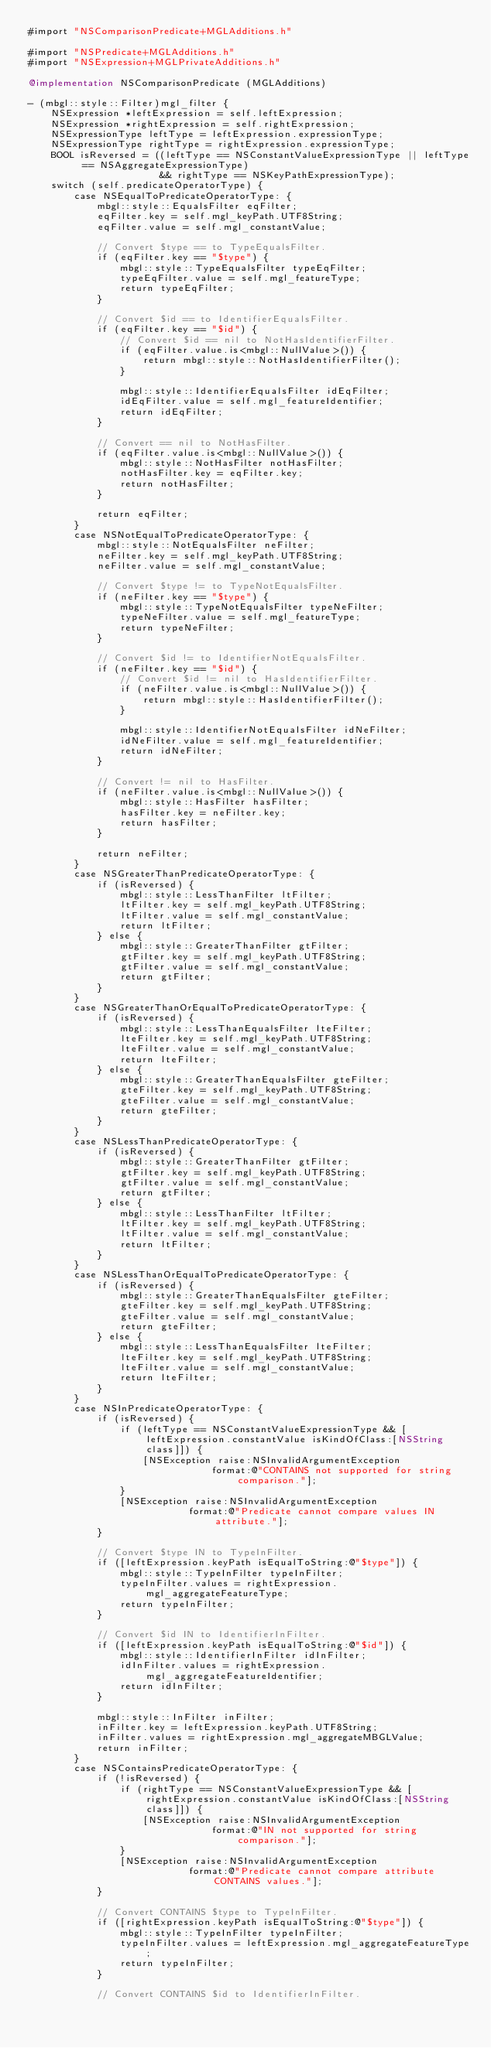<code> <loc_0><loc_0><loc_500><loc_500><_ObjectiveC_>#import "NSComparisonPredicate+MGLAdditions.h"

#import "NSPredicate+MGLAdditions.h"
#import "NSExpression+MGLPrivateAdditions.h"

@implementation NSComparisonPredicate (MGLAdditions)

- (mbgl::style::Filter)mgl_filter {
    NSExpression *leftExpression = self.leftExpression;
    NSExpression *rightExpression = self.rightExpression;
    NSExpressionType leftType = leftExpression.expressionType;
    NSExpressionType rightType = rightExpression.expressionType;
    BOOL isReversed = ((leftType == NSConstantValueExpressionType || leftType == NSAggregateExpressionType)
                       && rightType == NSKeyPathExpressionType);
    switch (self.predicateOperatorType) {
        case NSEqualToPredicateOperatorType: {
            mbgl::style::EqualsFilter eqFilter;
            eqFilter.key = self.mgl_keyPath.UTF8String;
            eqFilter.value = self.mgl_constantValue;
            
            // Convert $type == to TypeEqualsFilter.
            if (eqFilter.key == "$type") {
                mbgl::style::TypeEqualsFilter typeEqFilter;
                typeEqFilter.value = self.mgl_featureType;
                return typeEqFilter;
            }
            
            // Convert $id == to IdentifierEqualsFilter.
            if (eqFilter.key == "$id") {
                // Convert $id == nil to NotHasIdentifierFilter.
                if (eqFilter.value.is<mbgl::NullValue>()) {
                    return mbgl::style::NotHasIdentifierFilter();
                }
                
                mbgl::style::IdentifierEqualsFilter idEqFilter;
                idEqFilter.value = self.mgl_featureIdentifier;
                return idEqFilter;
            }

            // Convert == nil to NotHasFilter.
            if (eqFilter.value.is<mbgl::NullValue>()) {
                mbgl::style::NotHasFilter notHasFilter;
                notHasFilter.key = eqFilter.key;
                return notHasFilter;
            }

            return eqFilter;
        }
        case NSNotEqualToPredicateOperatorType: {
            mbgl::style::NotEqualsFilter neFilter;
            neFilter.key = self.mgl_keyPath.UTF8String;
            neFilter.value = self.mgl_constantValue;
            
            // Convert $type != to TypeNotEqualsFilter.
            if (neFilter.key == "$type") {
                mbgl::style::TypeNotEqualsFilter typeNeFilter;
                typeNeFilter.value = self.mgl_featureType;
                return typeNeFilter;
            }
            
            // Convert $id != to IdentifierNotEqualsFilter.
            if (neFilter.key == "$id") {
                // Convert $id != nil to HasIdentifierFilter.
                if (neFilter.value.is<mbgl::NullValue>()) {
                    return mbgl::style::HasIdentifierFilter();
                }
                
                mbgl::style::IdentifierNotEqualsFilter idNeFilter;
                idNeFilter.value = self.mgl_featureIdentifier;
                return idNeFilter;
            }

            // Convert != nil to HasFilter.
            if (neFilter.value.is<mbgl::NullValue>()) {
                mbgl::style::HasFilter hasFilter;
                hasFilter.key = neFilter.key;
                return hasFilter;
            }

            return neFilter;
        }
        case NSGreaterThanPredicateOperatorType: {
            if (isReversed) {
                mbgl::style::LessThanFilter ltFilter;
                ltFilter.key = self.mgl_keyPath.UTF8String;
                ltFilter.value = self.mgl_constantValue;
                return ltFilter;
            } else {
                mbgl::style::GreaterThanFilter gtFilter;
                gtFilter.key = self.mgl_keyPath.UTF8String;
                gtFilter.value = self.mgl_constantValue;
                return gtFilter;
            }
        }
        case NSGreaterThanOrEqualToPredicateOperatorType: {
            if (isReversed) {
                mbgl::style::LessThanEqualsFilter lteFilter;
                lteFilter.key = self.mgl_keyPath.UTF8String;
                lteFilter.value = self.mgl_constantValue;
                return lteFilter;
            } else {
                mbgl::style::GreaterThanEqualsFilter gteFilter;
                gteFilter.key = self.mgl_keyPath.UTF8String;
                gteFilter.value = self.mgl_constantValue;
                return gteFilter;
            }
        }
        case NSLessThanPredicateOperatorType: {
            if (isReversed) {
                mbgl::style::GreaterThanFilter gtFilter;
                gtFilter.key = self.mgl_keyPath.UTF8String;
                gtFilter.value = self.mgl_constantValue;
                return gtFilter;
            } else {
                mbgl::style::LessThanFilter ltFilter;
                ltFilter.key = self.mgl_keyPath.UTF8String;
                ltFilter.value = self.mgl_constantValue;
                return ltFilter;
            }
        }
        case NSLessThanOrEqualToPredicateOperatorType: {
            if (isReversed) {
                mbgl::style::GreaterThanEqualsFilter gteFilter;
                gteFilter.key = self.mgl_keyPath.UTF8String;
                gteFilter.value = self.mgl_constantValue;
                return gteFilter;
            } else {
                mbgl::style::LessThanEqualsFilter lteFilter;
                lteFilter.key = self.mgl_keyPath.UTF8String;
                lteFilter.value = self.mgl_constantValue;
                return lteFilter;
            }
        }
        case NSInPredicateOperatorType: {
            if (isReversed) {
                if (leftType == NSConstantValueExpressionType && [leftExpression.constantValue isKindOfClass:[NSString class]]) {
                    [NSException raise:NSInvalidArgumentException
                                format:@"CONTAINS not supported for string comparison."];
                }
                [NSException raise:NSInvalidArgumentException
                            format:@"Predicate cannot compare values IN attribute."];
            }
            
            // Convert $type IN to TypeInFilter.
            if ([leftExpression.keyPath isEqualToString:@"$type"]) {
                mbgl::style::TypeInFilter typeInFilter;
                typeInFilter.values = rightExpression.mgl_aggregateFeatureType;
                return typeInFilter;
            }
            
            // Convert $id IN to IdentifierInFilter.
            if ([leftExpression.keyPath isEqualToString:@"$id"]) {
                mbgl::style::IdentifierInFilter idInFilter;
                idInFilter.values = rightExpression.mgl_aggregateFeatureIdentifier;
                return idInFilter;
            }
            
            mbgl::style::InFilter inFilter;
            inFilter.key = leftExpression.keyPath.UTF8String;
            inFilter.values = rightExpression.mgl_aggregateMBGLValue;
            return inFilter;
        }
        case NSContainsPredicateOperatorType: {
            if (!isReversed) {
                if (rightType == NSConstantValueExpressionType && [rightExpression.constantValue isKindOfClass:[NSString class]]) {
                    [NSException raise:NSInvalidArgumentException
                                format:@"IN not supported for string comparison."];
                }
                [NSException raise:NSInvalidArgumentException
                            format:@"Predicate cannot compare attribute CONTAINS values."];
            }
            
            // Convert CONTAINS $type to TypeInFilter.
            if ([rightExpression.keyPath isEqualToString:@"$type"]) {
                mbgl::style::TypeInFilter typeInFilter;
                typeInFilter.values = leftExpression.mgl_aggregateFeatureType;
                return typeInFilter;
            }
            
            // Convert CONTAINS $id to IdentifierInFilter.</code> 